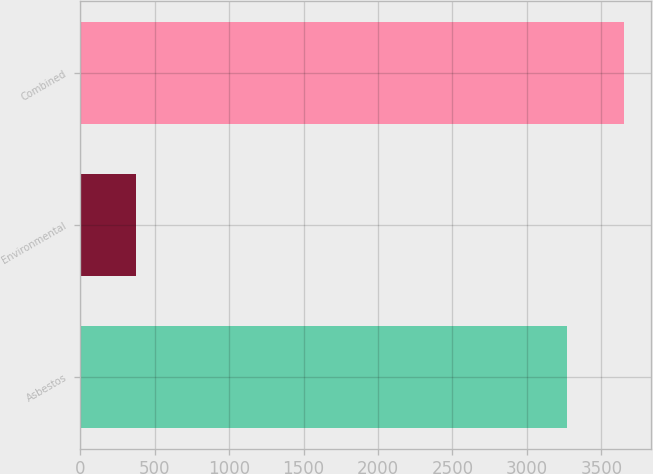Convert chart to OTSL. <chart><loc_0><loc_0><loc_500><loc_500><bar_chart><fcel>Asbestos<fcel>Environmental<fcel>Combined<nl><fcel>3270<fcel>378<fcel>3648<nl></chart> 